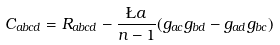Convert formula to latex. <formula><loc_0><loc_0><loc_500><loc_500>C _ { a b c d } = R _ { a b c d } - \frac { \L a } { n - 1 } ( g _ { a c } g _ { b d } - g _ { a d } g _ { b c } )</formula> 